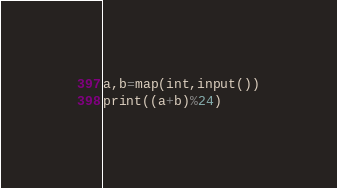<code> <loc_0><loc_0><loc_500><loc_500><_Python_>a,b=map(int,input())
print((a+b)%24)</code> 